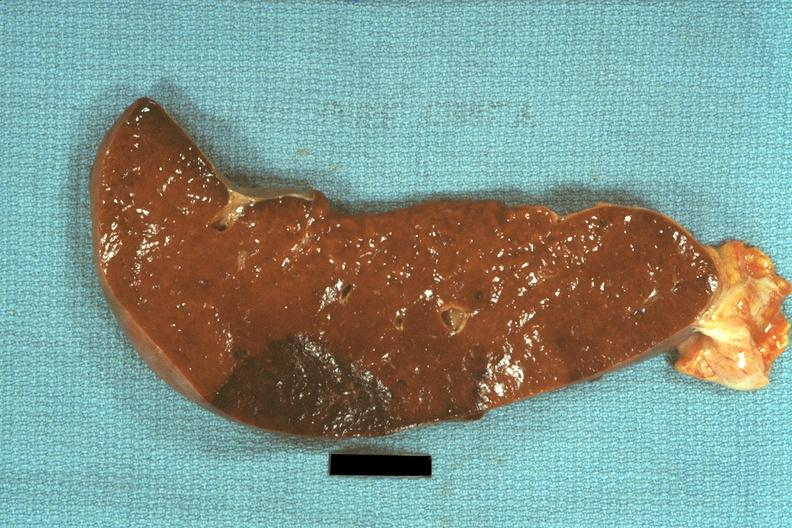what does this image show?
Answer the question using a single word or phrase. Typical dark infarct 